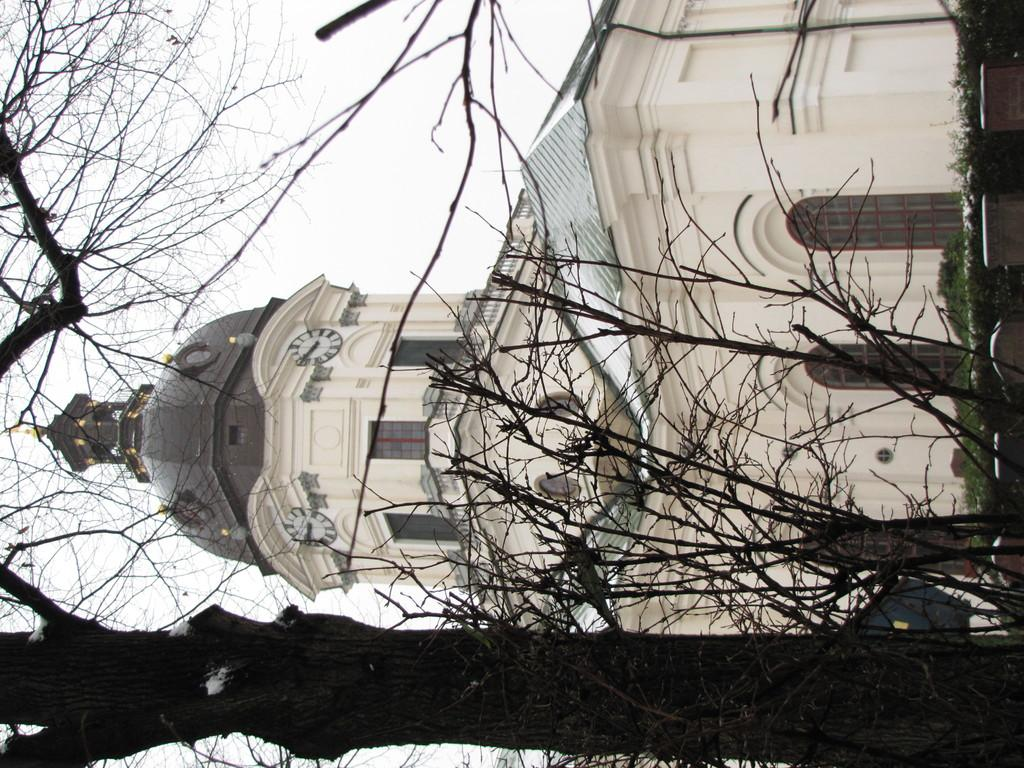What is the main structure in the middle of the image? There is a building in the middle of the image. What type of vegetation is present at the left side of the image? There is a tree at the left side of the image. What part of the natural environment is visible in the image? The sky is visible at the top left side of the image. Where is the scarecrow located in the image? There is no scarecrow present in the image. What type of animal is grazing near the tree in the image? There is no animal, such as a goat, present in the image. 